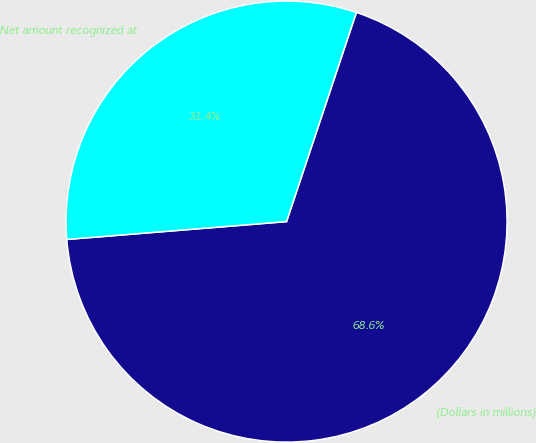Convert chart to OTSL. <chart><loc_0><loc_0><loc_500><loc_500><pie_chart><fcel>(Dollars in millions)<fcel>Net amount recognized at<nl><fcel>68.58%<fcel>31.42%<nl></chart> 